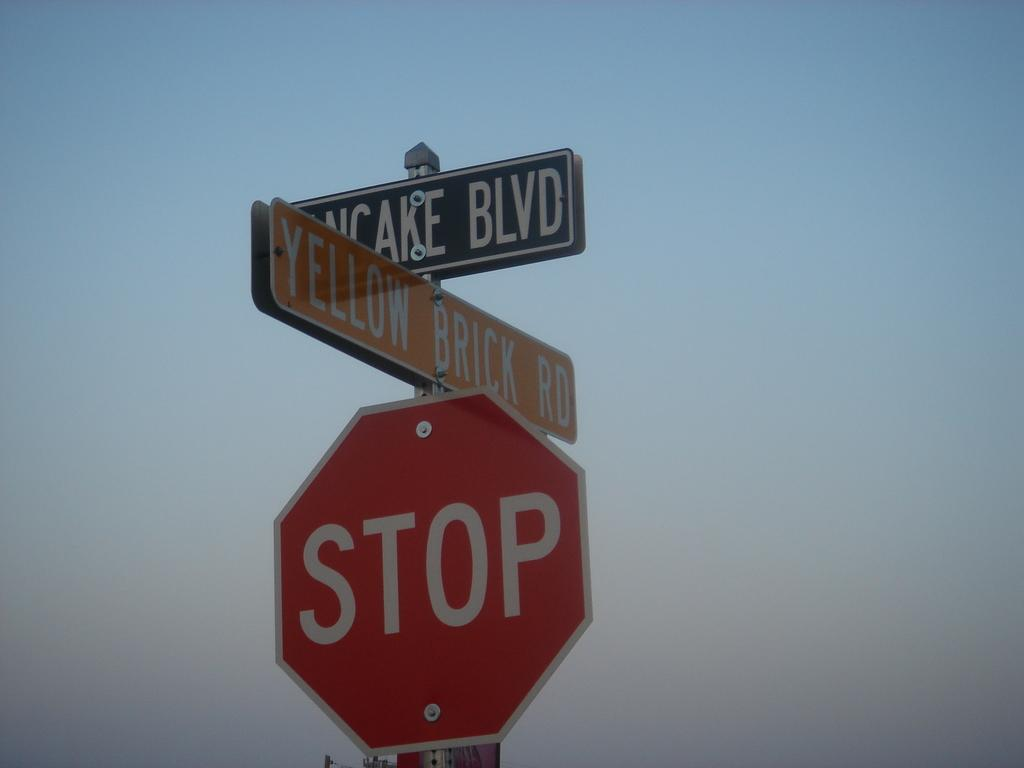Provide a one-sentence caption for the provided image. Yellow sign on top of a red stop sign. 